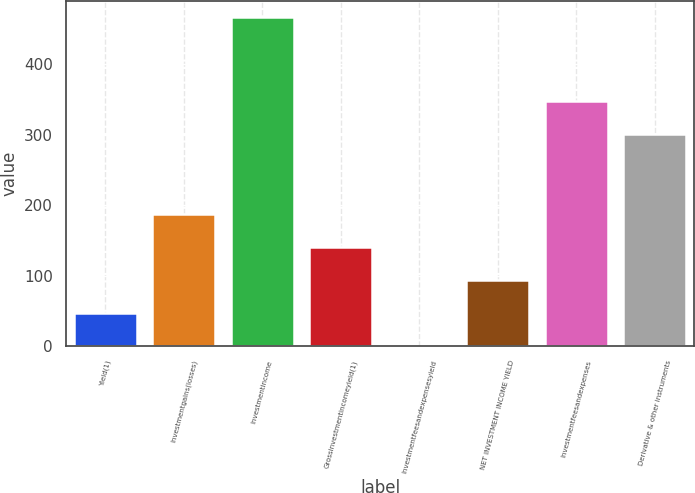Convert chart. <chart><loc_0><loc_0><loc_500><loc_500><bar_chart><fcel>Yield(1)<fcel>Investmentgains(losses)<fcel>Investmentincome<fcel>Grossinvestmentincomeyield(1)<fcel>Investmentfeesandexpensesyield<fcel>NET INVESTMENT INCOME YIELD<fcel>Investmentfeesandexpenses<fcel>Derivative & other instruments<nl><fcel>46.83<fcel>186.9<fcel>467<fcel>140.21<fcel>0.14<fcel>93.52<fcel>347.69<fcel>301<nl></chart> 